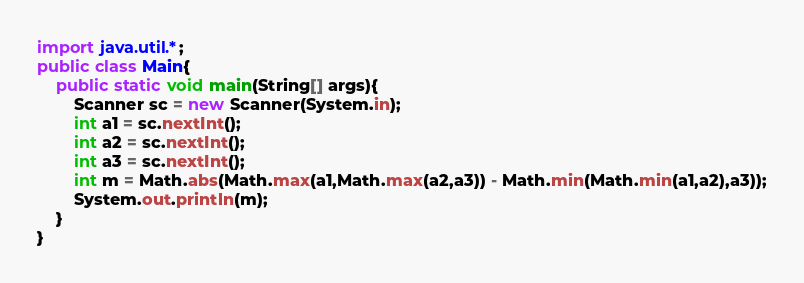<code> <loc_0><loc_0><loc_500><loc_500><_Java_>import java.util.*;
public class Main{
	public static void main(String[] args){
        Scanner sc = new Scanner(System.in);
        int a1 = sc.nextInt();
        int a2 = sc.nextInt();
        int a3 = sc.nextInt();
        int m = Math.abs(Math.max(a1,Math.max(a2,a3)) - Math.min(Math.min(a1,a2),a3));
        System.out.println(m);
    }
}
</code> 